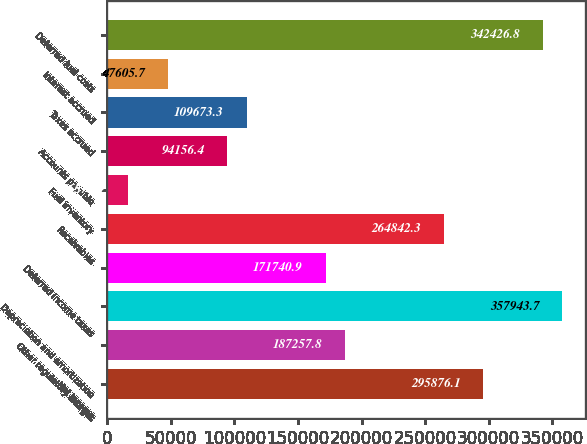Convert chart. <chart><loc_0><loc_0><loc_500><loc_500><bar_chart><fcel>Net income<fcel>Other regulatory charges<fcel>Depreciation and amortization<fcel>Deferred income taxes<fcel>Receivables<fcel>Fuel inventory<fcel>Accounts payable<fcel>Taxes accrued<fcel>Interest accrued<fcel>Deferred fuel costs<nl><fcel>295876<fcel>187258<fcel>357944<fcel>171741<fcel>264842<fcel>16571.9<fcel>94156.4<fcel>109673<fcel>47605.7<fcel>342427<nl></chart> 